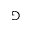<formula> <loc_0><loc_0><loc_500><loc_500>\ G a m e</formula> 